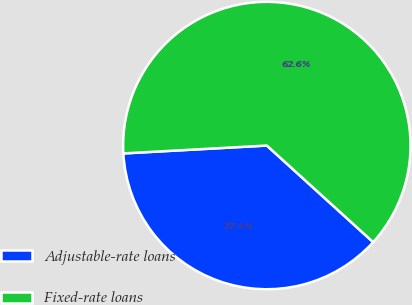<chart> <loc_0><loc_0><loc_500><loc_500><pie_chart><fcel>Adjustable-rate loans<fcel>Fixed-rate loans<nl><fcel>37.39%<fcel>62.61%<nl></chart> 